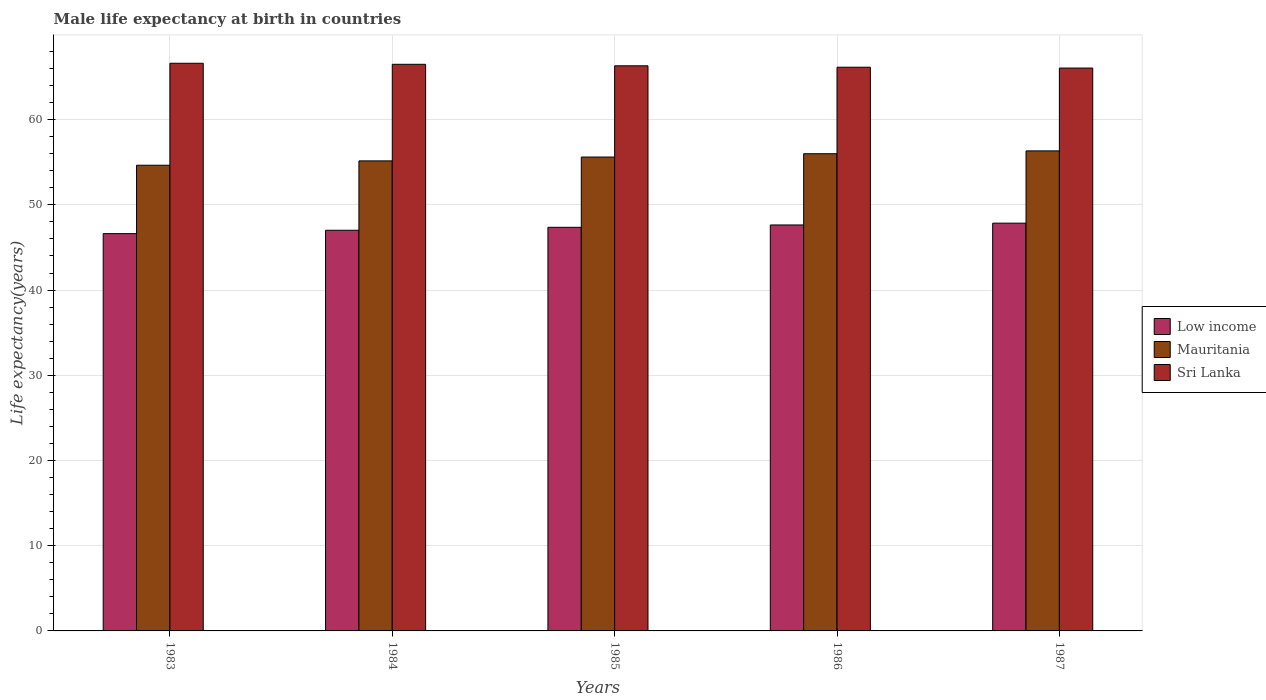How many different coloured bars are there?
Keep it short and to the point. 3. Are the number of bars per tick equal to the number of legend labels?
Your answer should be very brief. Yes. How many bars are there on the 1st tick from the left?
Your answer should be compact. 3. How many bars are there on the 3rd tick from the right?
Your answer should be compact. 3. What is the male life expectancy at birth in Mauritania in 1987?
Ensure brevity in your answer.  56.33. Across all years, what is the maximum male life expectancy at birth in Mauritania?
Keep it short and to the point. 56.33. Across all years, what is the minimum male life expectancy at birth in Mauritania?
Offer a terse response. 54.65. In which year was the male life expectancy at birth in Mauritania minimum?
Ensure brevity in your answer.  1983. What is the total male life expectancy at birth in Sri Lanka in the graph?
Make the answer very short. 331.62. What is the difference between the male life expectancy at birth in Sri Lanka in 1984 and that in 1986?
Provide a succinct answer. 0.34. What is the difference between the male life expectancy at birth in Mauritania in 1987 and the male life expectancy at birth in Sri Lanka in 1983?
Ensure brevity in your answer.  -10.28. What is the average male life expectancy at birth in Low income per year?
Make the answer very short. 47.3. In the year 1983, what is the difference between the male life expectancy at birth in Mauritania and male life expectancy at birth in Low income?
Your answer should be very brief. 8.03. In how many years, is the male life expectancy at birth in Low income greater than 40 years?
Offer a very short reply. 5. What is the ratio of the male life expectancy at birth in Mauritania in 1983 to that in 1985?
Your answer should be very brief. 0.98. Is the male life expectancy at birth in Mauritania in 1983 less than that in 1985?
Provide a short and direct response. Yes. What is the difference between the highest and the second highest male life expectancy at birth in Sri Lanka?
Ensure brevity in your answer.  0.12. What is the difference between the highest and the lowest male life expectancy at birth in Low income?
Provide a short and direct response. 1.23. In how many years, is the male life expectancy at birth in Mauritania greater than the average male life expectancy at birth in Mauritania taken over all years?
Give a very brief answer. 3. What does the 2nd bar from the left in 1985 represents?
Keep it short and to the point. Mauritania. What does the 2nd bar from the right in 1986 represents?
Your answer should be very brief. Mauritania. Is it the case that in every year, the sum of the male life expectancy at birth in Low income and male life expectancy at birth in Mauritania is greater than the male life expectancy at birth in Sri Lanka?
Provide a short and direct response. Yes. How many bars are there?
Provide a short and direct response. 15. What is the difference between two consecutive major ticks on the Y-axis?
Provide a short and direct response. 10. Does the graph contain any zero values?
Provide a succinct answer. No. How are the legend labels stacked?
Ensure brevity in your answer.  Vertical. What is the title of the graph?
Your response must be concise. Male life expectancy at birth in countries. Does "Korea (Republic)" appear as one of the legend labels in the graph?
Offer a terse response. No. What is the label or title of the X-axis?
Make the answer very short. Years. What is the label or title of the Y-axis?
Offer a very short reply. Life expectancy(years). What is the Life expectancy(years) in Low income in 1983?
Your answer should be very brief. 46.62. What is the Life expectancy(years) in Mauritania in 1983?
Offer a terse response. 54.65. What is the Life expectancy(years) in Sri Lanka in 1983?
Your answer should be very brief. 66.61. What is the Life expectancy(years) in Low income in 1984?
Ensure brevity in your answer.  47.02. What is the Life expectancy(years) of Mauritania in 1984?
Keep it short and to the point. 55.16. What is the Life expectancy(years) in Sri Lanka in 1984?
Provide a short and direct response. 66.49. What is the Life expectancy(years) in Low income in 1985?
Give a very brief answer. 47.36. What is the Life expectancy(years) of Mauritania in 1985?
Provide a short and direct response. 55.61. What is the Life expectancy(years) of Sri Lanka in 1985?
Your answer should be compact. 66.31. What is the Life expectancy(years) in Low income in 1986?
Your answer should be compact. 47.64. What is the Life expectancy(years) of Mauritania in 1986?
Provide a short and direct response. 56. What is the Life expectancy(years) of Sri Lanka in 1986?
Ensure brevity in your answer.  66.15. What is the Life expectancy(years) of Low income in 1987?
Offer a terse response. 47.85. What is the Life expectancy(years) of Mauritania in 1987?
Offer a terse response. 56.33. What is the Life expectancy(years) in Sri Lanka in 1987?
Keep it short and to the point. 66.05. Across all years, what is the maximum Life expectancy(years) of Low income?
Your answer should be very brief. 47.85. Across all years, what is the maximum Life expectancy(years) of Mauritania?
Make the answer very short. 56.33. Across all years, what is the maximum Life expectancy(years) of Sri Lanka?
Your answer should be very brief. 66.61. Across all years, what is the minimum Life expectancy(years) in Low income?
Keep it short and to the point. 46.62. Across all years, what is the minimum Life expectancy(years) of Mauritania?
Your answer should be compact. 54.65. Across all years, what is the minimum Life expectancy(years) in Sri Lanka?
Offer a terse response. 66.05. What is the total Life expectancy(years) of Low income in the graph?
Give a very brief answer. 236.49. What is the total Life expectancy(years) in Mauritania in the graph?
Offer a very short reply. 277.74. What is the total Life expectancy(years) of Sri Lanka in the graph?
Offer a very short reply. 331.62. What is the difference between the Life expectancy(years) in Low income in 1983 and that in 1984?
Keep it short and to the point. -0.4. What is the difference between the Life expectancy(years) in Mauritania in 1983 and that in 1984?
Provide a succinct answer. -0.51. What is the difference between the Life expectancy(years) of Sri Lanka in 1983 and that in 1984?
Your answer should be very brief. 0.12. What is the difference between the Life expectancy(years) of Low income in 1983 and that in 1985?
Your answer should be very brief. -0.74. What is the difference between the Life expectancy(years) in Mauritania in 1983 and that in 1985?
Your answer should be very brief. -0.96. What is the difference between the Life expectancy(years) in Sri Lanka in 1983 and that in 1985?
Give a very brief answer. 0.3. What is the difference between the Life expectancy(years) in Low income in 1983 and that in 1986?
Offer a very short reply. -1.02. What is the difference between the Life expectancy(years) of Mauritania in 1983 and that in 1986?
Your answer should be very brief. -1.35. What is the difference between the Life expectancy(years) in Sri Lanka in 1983 and that in 1986?
Your answer should be compact. 0.46. What is the difference between the Life expectancy(years) in Low income in 1983 and that in 1987?
Offer a very short reply. -1.23. What is the difference between the Life expectancy(years) of Mauritania in 1983 and that in 1987?
Provide a succinct answer. -1.68. What is the difference between the Life expectancy(years) of Sri Lanka in 1983 and that in 1987?
Provide a succinct answer. 0.56. What is the difference between the Life expectancy(years) of Low income in 1984 and that in 1985?
Provide a succinct answer. -0.34. What is the difference between the Life expectancy(years) of Mauritania in 1984 and that in 1985?
Your response must be concise. -0.45. What is the difference between the Life expectancy(years) of Sri Lanka in 1984 and that in 1985?
Your answer should be very brief. 0.18. What is the difference between the Life expectancy(years) in Low income in 1984 and that in 1986?
Ensure brevity in your answer.  -0.62. What is the difference between the Life expectancy(years) in Mauritania in 1984 and that in 1986?
Your answer should be compact. -0.84. What is the difference between the Life expectancy(years) of Sri Lanka in 1984 and that in 1986?
Make the answer very short. 0.34. What is the difference between the Life expectancy(years) of Low income in 1984 and that in 1987?
Offer a very short reply. -0.83. What is the difference between the Life expectancy(years) in Mauritania in 1984 and that in 1987?
Make the answer very short. -1.17. What is the difference between the Life expectancy(years) in Sri Lanka in 1984 and that in 1987?
Offer a terse response. 0.44. What is the difference between the Life expectancy(years) of Low income in 1985 and that in 1986?
Offer a very short reply. -0.28. What is the difference between the Life expectancy(years) of Mauritania in 1985 and that in 1986?
Your answer should be very brief. -0.39. What is the difference between the Life expectancy(years) of Sri Lanka in 1985 and that in 1986?
Your answer should be compact. 0.17. What is the difference between the Life expectancy(years) in Low income in 1985 and that in 1987?
Provide a short and direct response. -0.49. What is the difference between the Life expectancy(years) in Mauritania in 1985 and that in 1987?
Your response must be concise. -0.72. What is the difference between the Life expectancy(years) of Sri Lanka in 1985 and that in 1987?
Offer a terse response. 0.26. What is the difference between the Life expectancy(years) of Low income in 1986 and that in 1987?
Keep it short and to the point. -0.21. What is the difference between the Life expectancy(years) of Mauritania in 1986 and that in 1987?
Make the answer very short. -0.33. What is the difference between the Life expectancy(years) in Sri Lanka in 1986 and that in 1987?
Keep it short and to the point. 0.1. What is the difference between the Life expectancy(years) in Low income in 1983 and the Life expectancy(years) in Mauritania in 1984?
Your answer should be compact. -8.54. What is the difference between the Life expectancy(years) of Low income in 1983 and the Life expectancy(years) of Sri Lanka in 1984?
Offer a terse response. -19.87. What is the difference between the Life expectancy(years) of Mauritania in 1983 and the Life expectancy(years) of Sri Lanka in 1984?
Provide a succinct answer. -11.84. What is the difference between the Life expectancy(years) in Low income in 1983 and the Life expectancy(years) in Mauritania in 1985?
Provide a succinct answer. -8.99. What is the difference between the Life expectancy(years) in Low income in 1983 and the Life expectancy(years) in Sri Lanka in 1985?
Provide a succinct answer. -19.69. What is the difference between the Life expectancy(years) of Mauritania in 1983 and the Life expectancy(years) of Sri Lanka in 1985?
Offer a very short reply. -11.67. What is the difference between the Life expectancy(years) in Low income in 1983 and the Life expectancy(years) in Mauritania in 1986?
Give a very brief answer. -9.38. What is the difference between the Life expectancy(years) in Low income in 1983 and the Life expectancy(years) in Sri Lanka in 1986?
Ensure brevity in your answer.  -19.53. What is the difference between the Life expectancy(years) in Mauritania in 1983 and the Life expectancy(years) in Sri Lanka in 1986?
Offer a terse response. -11.5. What is the difference between the Life expectancy(years) in Low income in 1983 and the Life expectancy(years) in Mauritania in 1987?
Ensure brevity in your answer.  -9.71. What is the difference between the Life expectancy(years) of Low income in 1983 and the Life expectancy(years) of Sri Lanka in 1987?
Keep it short and to the point. -19.43. What is the difference between the Life expectancy(years) of Mauritania in 1983 and the Life expectancy(years) of Sri Lanka in 1987?
Offer a terse response. -11.4. What is the difference between the Life expectancy(years) in Low income in 1984 and the Life expectancy(years) in Mauritania in 1985?
Your answer should be very brief. -8.59. What is the difference between the Life expectancy(years) in Low income in 1984 and the Life expectancy(years) in Sri Lanka in 1985?
Give a very brief answer. -19.3. What is the difference between the Life expectancy(years) in Mauritania in 1984 and the Life expectancy(years) in Sri Lanka in 1985?
Give a very brief answer. -11.16. What is the difference between the Life expectancy(years) of Low income in 1984 and the Life expectancy(years) of Mauritania in 1986?
Your answer should be very brief. -8.98. What is the difference between the Life expectancy(years) in Low income in 1984 and the Life expectancy(years) in Sri Lanka in 1986?
Offer a very short reply. -19.13. What is the difference between the Life expectancy(years) in Mauritania in 1984 and the Life expectancy(years) in Sri Lanka in 1986?
Offer a terse response. -10.99. What is the difference between the Life expectancy(years) of Low income in 1984 and the Life expectancy(years) of Mauritania in 1987?
Offer a very short reply. -9.31. What is the difference between the Life expectancy(years) of Low income in 1984 and the Life expectancy(years) of Sri Lanka in 1987?
Give a very brief answer. -19.03. What is the difference between the Life expectancy(years) in Mauritania in 1984 and the Life expectancy(years) in Sri Lanka in 1987?
Your answer should be compact. -10.89. What is the difference between the Life expectancy(years) of Low income in 1985 and the Life expectancy(years) of Mauritania in 1986?
Your answer should be very brief. -8.64. What is the difference between the Life expectancy(years) in Low income in 1985 and the Life expectancy(years) in Sri Lanka in 1986?
Your answer should be compact. -18.79. What is the difference between the Life expectancy(years) in Mauritania in 1985 and the Life expectancy(years) in Sri Lanka in 1986?
Your answer should be compact. -10.54. What is the difference between the Life expectancy(years) of Low income in 1985 and the Life expectancy(years) of Mauritania in 1987?
Provide a succinct answer. -8.97. What is the difference between the Life expectancy(years) of Low income in 1985 and the Life expectancy(years) of Sri Lanka in 1987?
Provide a succinct answer. -18.69. What is the difference between the Life expectancy(years) in Mauritania in 1985 and the Life expectancy(years) in Sri Lanka in 1987?
Keep it short and to the point. -10.44. What is the difference between the Life expectancy(years) in Low income in 1986 and the Life expectancy(years) in Mauritania in 1987?
Offer a terse response. -8.69. What is the difference between the Life expectancy(years) in Low income in 1986 and the Life expectancy(years) in Sri Lanka in 1987?
Ensure brevity in your answer.  -18.41. What is the difference between the Life expectancy(years) of Mauritania in 1986 and the Life expectancy(years) of Sri Lanka in 1987?
Offer a very short reply. -10.05. What is the average Life expectancy(years) in Low income per year?
Give a very brief answer. 47.3. What is the average Life expectancy(years) in Mauritania per year?
Offer a terse response. 55.55. What is the average Life expectancy(years) in Sri Lanka per year?
Keep it short and to the point. 66.32. In the year 1983, what is the difference between the Life expectancy(years) of Low income and Life expectancy(years) of Mauritania?
Provide a succinct answer. -8.03. In the year 1983, what is the difference between the Life expectancy(years) in Low income and Life expectancy(years) in Sri Lanka?
Your answer should be compact. -19.99. In the year 1983, what is the difference between the Life expectancy(years) in Mauritania and Life expectancy(years) in Sri Lanka?
Provide a succinct answer. -11.97. In the year 1984, what is the difference between the Life expectancy(years) in Low income and Life expectancy(years) in Mauritania?
Your answer should be very brief. -8.14. In the year 1984, what is the difference between the Life expectancy(years) in Low income and Life expectancy(years) in Sri Lanka?
Provide a succinct answer. -19.47. In the year 1984, what is the difference between the Life expectancy(years) of Mauritania and Life expectancy(years) of Sri Lanka?
Keep it short and to the point. -11.33. In the year 1985, what is the difference between the Life expectancy(years) of Low income and Life expectancy(years) of Mauritania?
Offer a very short reply. -8.25. In the year 1985, what is the difference between the Life expectancy(years) in Low income and Life expectancy(years) in Sri Lanka?
Give a very brief answer. -18.95. In the year 1985, what is the difference between the Life expectancy(years) of Mauritania and Life expectancy(years) of Sri Lanka?
Keep it short and to the point. -10.71. In the year 1986, what is the difference between the Life expectancy(years) of Low income and Life expectancy(years) of Mauritania?
Your answer should be compact. -8.36. In the year 1986, what is the difference between the Life expectancy(years) of Low income and Life expectancy(years) of Sri Lanka?
Offer a very short reply. -18.51. In the year 1986, what is the difference between the Life expectancy(years) in Mauritania and Life expectancy(years) in Sri Lanka?
Provide a succinct answer. -10.15. In the year 1987, what is the difference between the Life expectancy(years) in Low income and Life expectancy(years) in Mauritania?
Provide a succinct answer. -8.48. In the year 1987, what is the difference between the Life expectancy(years) of Low income and Life expectancy(years) of Sri Lanka?
Provide a succinct answer. -18.2. In the year 1987, what is the difference between the Life expectancy(years) in Mauritania and Life expectancy(years) in Sri Lanka?
Make the answer very short. -9.72. What is the ratio of the Life expectancy(years) in Low income in 1983 to that in 1984?
Provide a short and direct response. 0.99. What is the ratio of the Life expectancy(years) of Low income in 1983 to that in 1985?
Your answer should be very brief. 0.98. What is the ratio of the Life expectancy(years) of Mauritania in 1983 to that in 1985?
Offer a terse response. 0.98. What is the ratio of the Life expectancy(years) of Low income in 1983 to that in 1986?
Give a very brief answer. 0.98. What is the ratio of the Life expectancy(years) in Mauritania in 1983 to that in 1986?
Give a very brief answer. 0.98. What is the ratio of the Life expectancy(years) in Low income in 1983 to that in 1987?
Provide a short and direct response. 0.97. What is the ratio of the Life expectancy(years) of Mauritania in 1983 to that in 1987?
Give a very brief answer. 0.97. What is the ratio of the Life expectancy(years) in Sri Lanka in 1983 to that in 1987?
Your answer should be very brief. 1.01. What is the ratio of the Life expectancy(years) of Low income in 1984 to that in 1985?
Your response must be concise. 0.99. What is the ratio of the Life expectancy(years) in Sri Lanka in 1984 to that in 1985?
Your answer should be compact. 1. What is the ratio of the Life expectancy(years) of Low income in 1984 to that in 1986?
Give a very brief answer. 0.99. What is the ratio of the Life expectancy(years) in Low income in 1984 to that in 1987?
Offer a very short reply. 0.98. What is the ratio of the Life expectancy(years) of Mauritania in 1984 to that in 1987?
Your answer should be very brief. 0.98. What is the ratio of the Life expectancy(years) in Sri Lanka in 1984 to that in 1987?
Make the answer very short. 1.01. What is the ratio of the Life expectancy(years) in Mauritania in 1985 to that in 1986?
Provide a short and direct response. 0.99. What is the ratio of the Life expectancy(years) in Sri Lanka in 1985 to that in 1986?
Ensure brevity in your answer.  1. What is the ratio of the Life expectancy(years) of Low income in 1985 to that in 1987?
Your answer should be compact. 0.99. What is the ratio of the Life expectancy(years) of Mauritania in 1985 to that in 1987?
Offer a terse response. 0.99. What is the ratio of the Life expectancy(years) in Mauritania in 1986 to that in 1987?
Your answer should be compact. 0.99. What is the ratio of the Life expectancy(years) of Sri Lanka in 1986 to that in 1987?
Ensure brevity in your answer.  1. What is the difference between the highest and the second highest Life expectancy(years) in Low income?
Make the answer very short. 0.21. What is the difference between the highest and the second highest Life expectancy(years) of Mauritania?
Provide a succinct answer. 0.33. What is the difference between the highest and the second highest Life expectancy(years) of Sri Lanka?
Give a very brief answer. 0.12. What is the difference between the highest and the lowest Life expectancy(years) in Low income?
Make the answer very short. 1.23. What is the difference between the highest and the lowest Life expectancy(years) in Mauritania?
Your answer should be very brief. 1.68. What is the difference between the highest and the lowest Life expectancy(years) of Sri Lanka?
Offer a terse response. 0.56. 